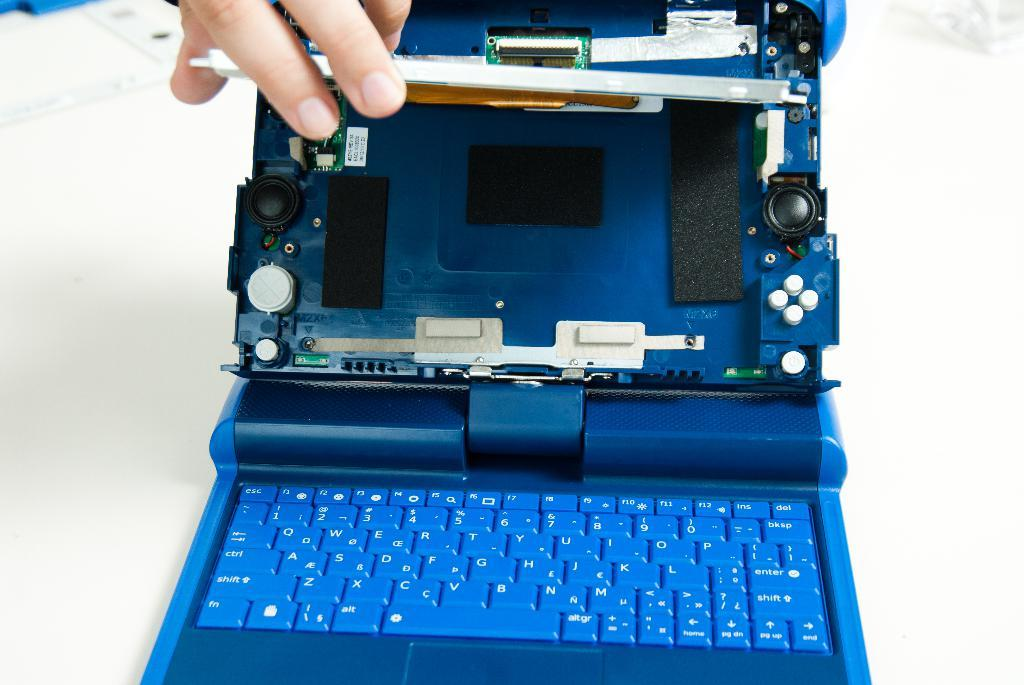<image>
Present a compact description of the photo's key features. A blue laptop with a QWERTY keyboard and a del and bksp button on the top right corner of the keyboard. 